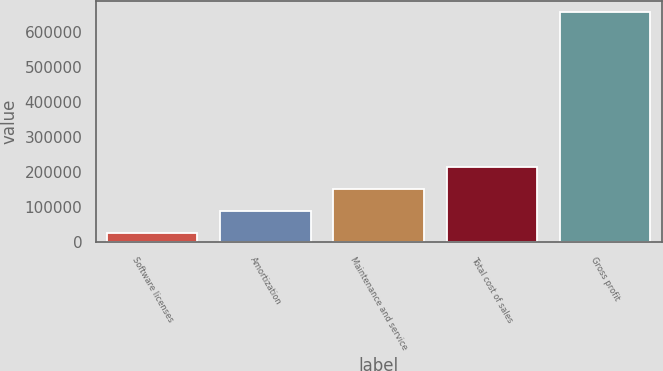Convert chart. <chart><loc_0><loc_0><loc_500><loc_500><bar_chart><fcel>Software licenses<fcel>Amortization<fcel>Maintenance and service<fcel>Total cost of sales<fcel>Gross profit<nl><fcel>24512<fcel>87911<fcel>151310<fcel>214709<fcel>658502<nl></chart> 